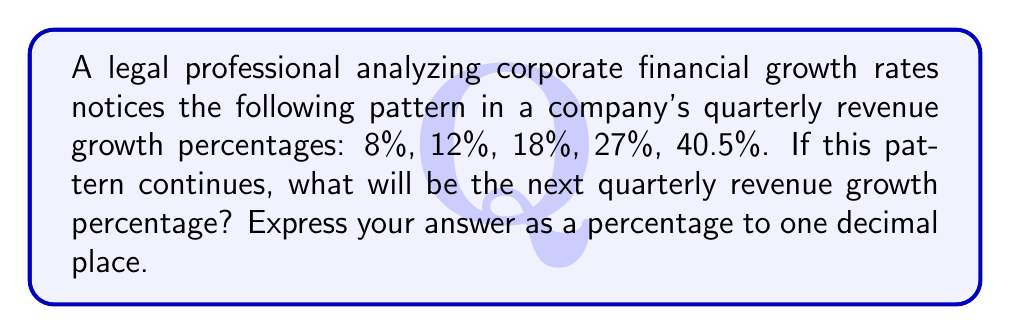Can you answer this question? To solve this problem, we need to identify the pattern in the given sequence of growth rates. Let's analyze the relationship between consecutive terms:

1) From 8% to 12%: $12 = 8 \times 1.5$
2) From 12% to 18%: $18 = 12 \times 1.5$
3) From 18% to 27%: $27 = 18 \times 1.5$
4) From 27% to 40.5%: $40.5 = 27 \times 1.5$

We can see that each term is 1.5 times the previous term. This is a geometric sequence with a common ratio of 1.5.

To find the next term, we multiply the last given term by 1.5:

$40.5\% \times 1.5 = 60.75\%$

Rounding to one decimal place: $60.8\%$

This growth pattern could be of particular interest in a legal context, as unusually consistent or extreme growth rates might warrant investigation for potential financial misconduct or market manipulation.
Answer: 60.8% 